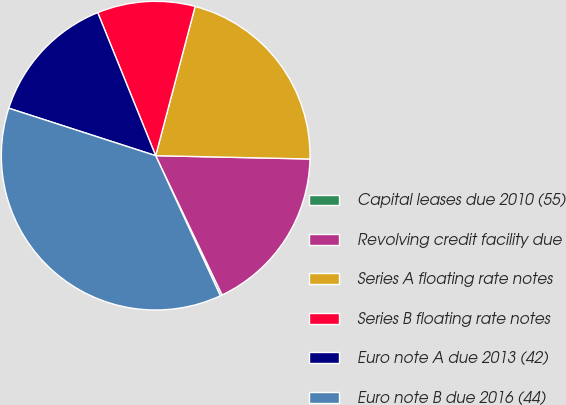<chart> <loc_0><loc_0><loc_500><loc_500><pie_chart><fcel>Capital leases due 2010 (55)<fcel>Revolving credit facility due<fcel>Series A floating rate notes<fcel>Series B floating rate notes<fcel>Euro note A due 2013 (42)<fcel>Euro note B due 2016 (44)<nl><fcel>0.2%<fcel>17.57%<fcel>21.23%<fcel>10.24%<fcel>13.9%<fcel>36.86%<nl></chart> 